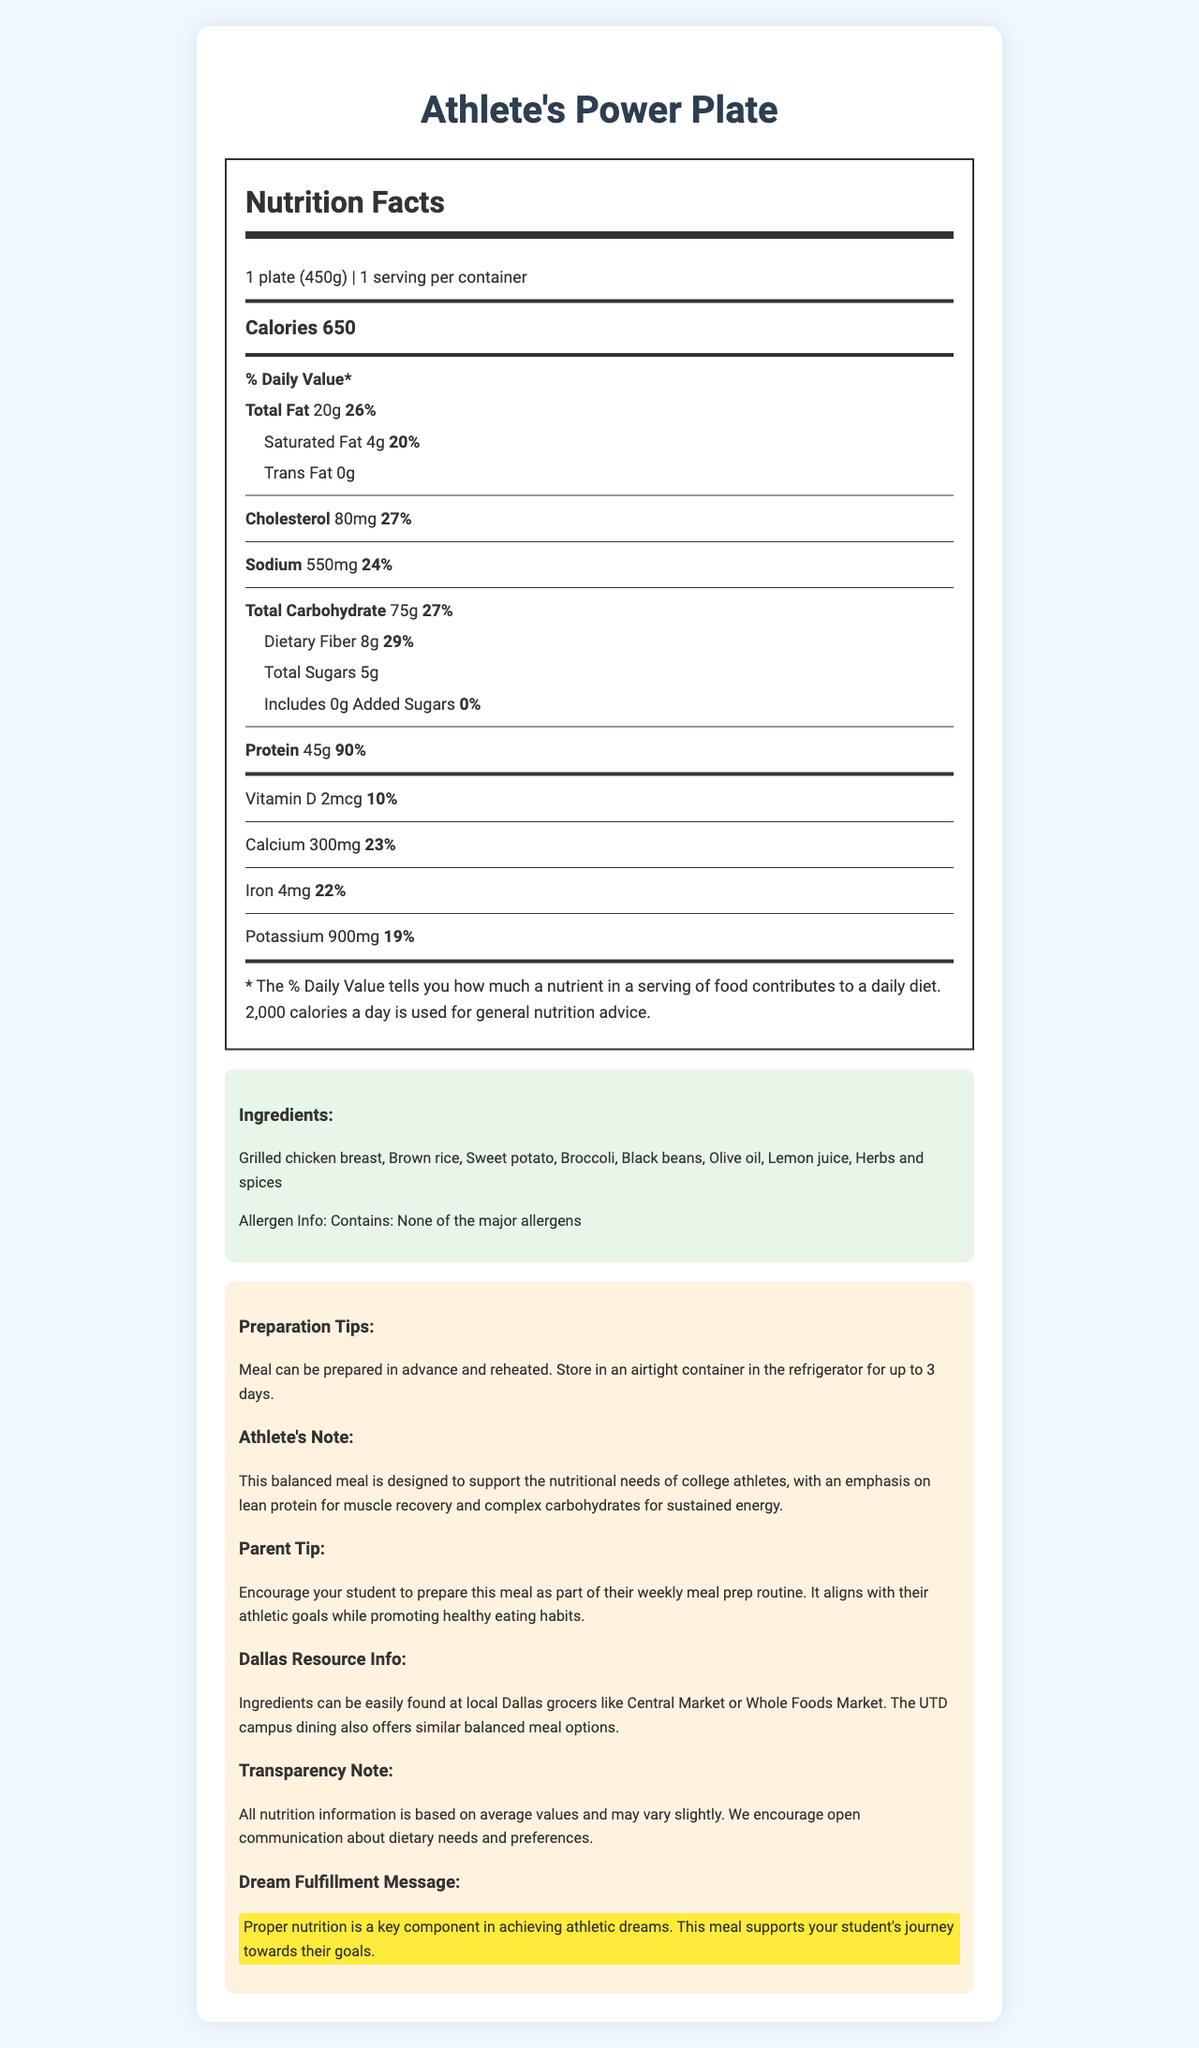what is the serving size of Athlete's Power Plate? The serving size of the product is specified in the nutrition facts section: "1 plate (450g)."
Answer: 1 plate (450g) how many calories are in one serving? The calories per serving are clearly indicated as 650 in the nutrition label.
Answer: 650 calories how much saturated fat is in the meal? The amount of saturated fat is listed under the total fat section: 4g.
Answer: 4g what percentage of the daily value of protein does the meal provide? The protein content and its daily value are mentioned as 45g and 90%, respectively, in the nutrition facts section.
Answer: 90% what are the primary ingredients in Athlete's Power Plate? The ingredients are detailed in the ingredients section of the document.
Answer: Grilled chicken breast, Brown rice, Sweet potato, Broccoli, Black beans, Olive oil, Lemon juice, Herbs and spices does the meal contain any major allergens? The allergen information section states: "Contains: None of the major allergens."
Answer: No where can the ingredients be sourced locally in Dallas?  A. Central Market B. Whole Foods Market C. Both The document mentions that ingredients can be found at both Central Market and Whole Foods Market.
Answer: C. Both what is the total amount of dietary fiber in the meal? A. 5g B. 8g C. 10g D. 15g The total dietary fiber content is specified as 8g in the nutrition facts.
Answer: B. 8g what is the sodium content in the meal? (in mg) The sodium content is listed as 550mg in the nutrition facts section.
Answer: 550mg does this meal include any added sugars? The added sugars section indicates 0g and 0% of daily value for added sugars.
Answer: No are there any preparation tips provided? The preparation tips section states, "Meal can be prepared in advance and reheated. Store in an airtight container in the refrigerator for up to 3 days."
Answer: Yes summarize the main purpose of the document. The document contains detailed information on nutritional content, ingredients, preparation tips, and supplementary notes aimed at supporting college athletes in maintaining a balanced diet.
Answer: The document provides comprehensive nutrition facts, ingredients, preparation tips, and additional notes about the Athlete's Power Plate, a balanced meal designed for college athletes, highlighting its nutritional benefits and supporting athletic and dream fulfillment goals. how does the meal support athletic performance? The athlete's note section explains that the meal is designed to support nutritional needs with an emphasis on lean protein for muscle recovery and complex carbohydrates for sustained energy.
Answer: Emphasizes lean protein for muscle recovery and complex carbohydrates for sustained energy. how much vitamin D does the meal provide? The vitamin D content is specified as 2mcg in the nutrition facts section.
Answer: 2mcg is the provided nutrition information exact? The transparency note mentions that all nutrition information is based on average values and may vary slightly.
Answer: No what percentage of the daily value does the total carbohydrate content represent? The daily value percentage for total carbohydrates is specified as 27%.
Answer: 27% can the exact cost of the meal be determined from the document? The document does not contain any information regarding the cost of the meal.
Answer: Cannot be determined what are the meal's benefits according to the dream fulfillment message? The dream fulfillment message states that proper nutrition is key to achieving athletic dreams and that this meal supports their journey towards those goals.
Answer: Supports the student's journey toward their athletic goals 